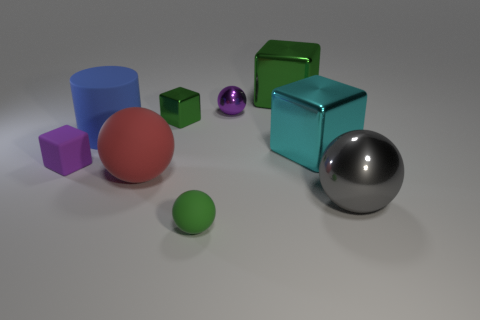Subtract 2 blocks. How many blocks are left? 2 Subtract all tiny purple metal balls. How many balls are left? 3 Subtract all blue balls. Subtract all green cylinders. How many balls are left? 4 Add 1 tiny balls. How many objects exist? 10 Subtract all cubes. How many objects are left? 5 Subtract all cyan blocks. Subtract all gray shiny objects. How many objects are left? 7 Add 1 big red objects. How many big red objects are left? 2 Add 9 large rubber balls. How many large rubber balls exist? 10 Subtract 1 red spheres. How many objects are left? 8 